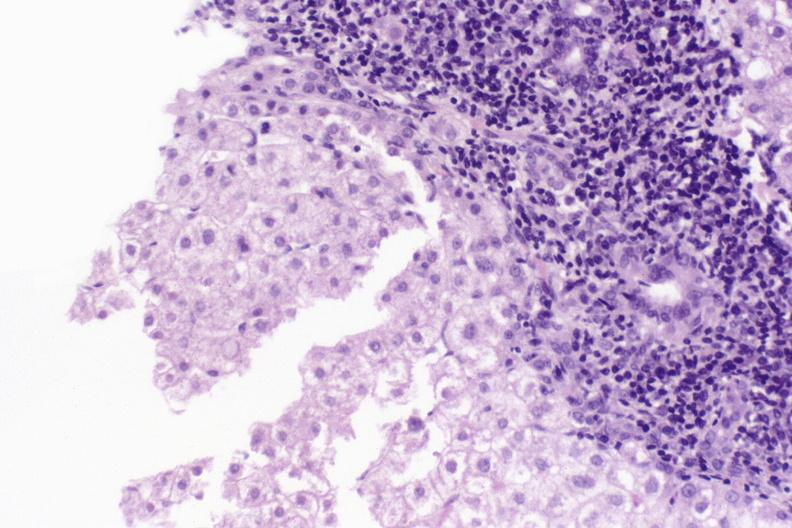what does this image show?
Answer the question using a single word or phrase. Primary biliary cirrhosis 